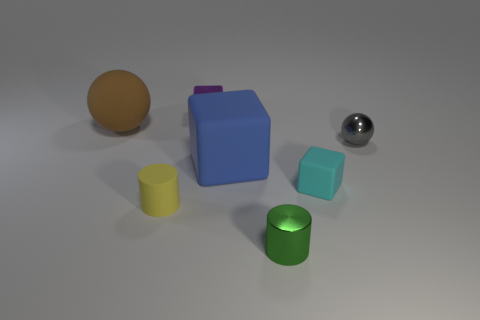What is the largest object in this image? The largest object in this image is the blue block, which has a prominent position in the center, displaying its solid and sizeable form. 